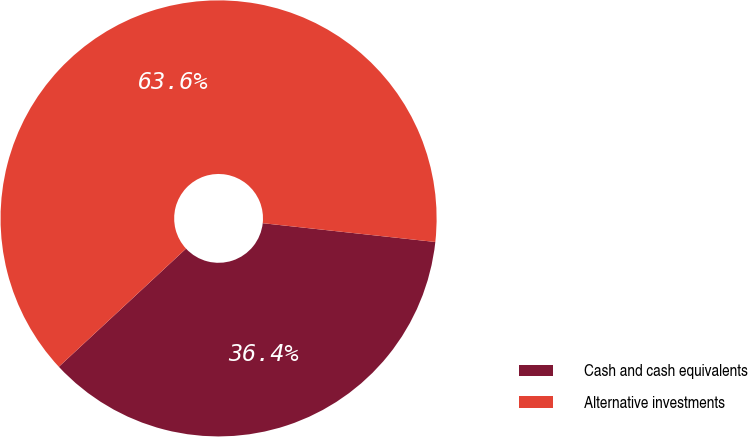<chart> <loc_0><loc_0><loc_500><loc_500><pie_chart><fcel>Cash and cash equivalents<fcel>Alternative investments<nl><fcel>36.36%<fcel>63.64%<nl></chart> 